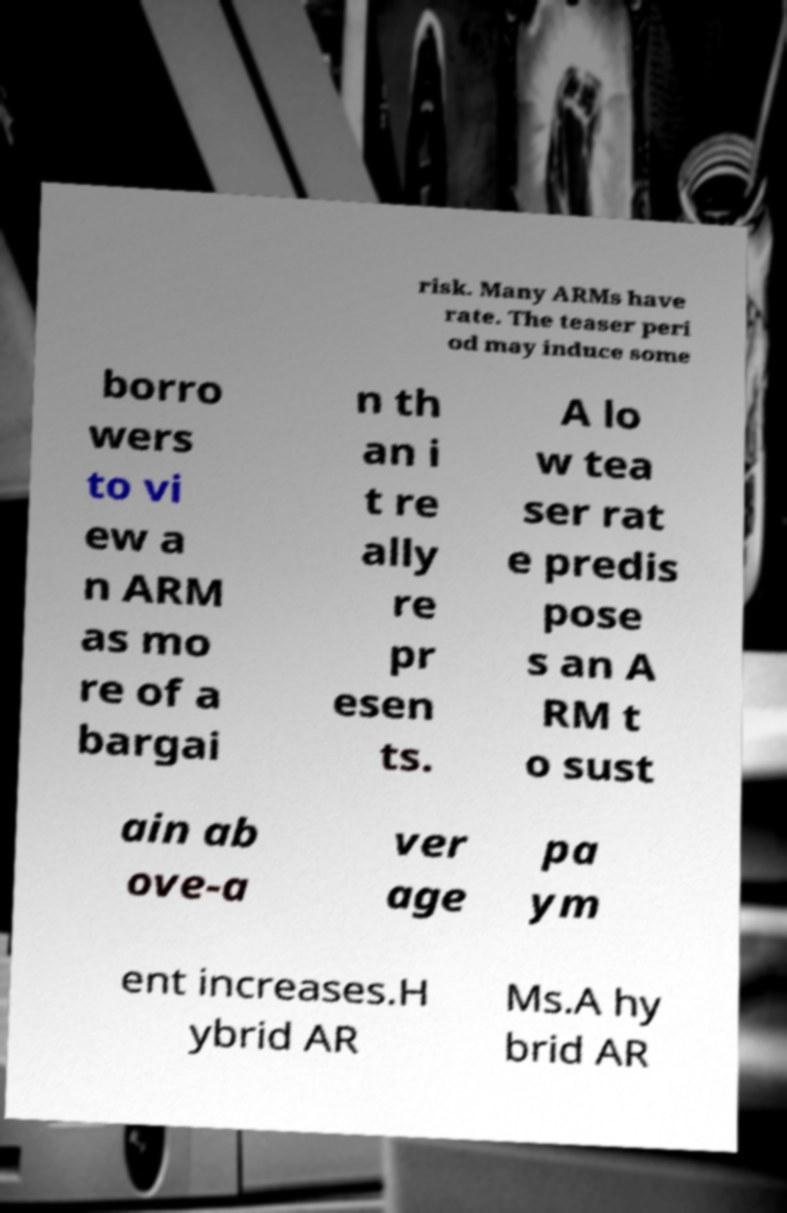There's text embedded in this image that I need extracted. Can you transcribe it verbatim? risk. Many ARMs have rate. The teaser peri od may induce some borro wers to vi ew a n ARM as mo re of a bargai n th an i t re ally re pr esen ts. A lo w tea ser rat e predis pose s an A RM t o sust ain ab ove-a ver age pa ym ent increases.H ybrid AR Ms.A hy brid AR 